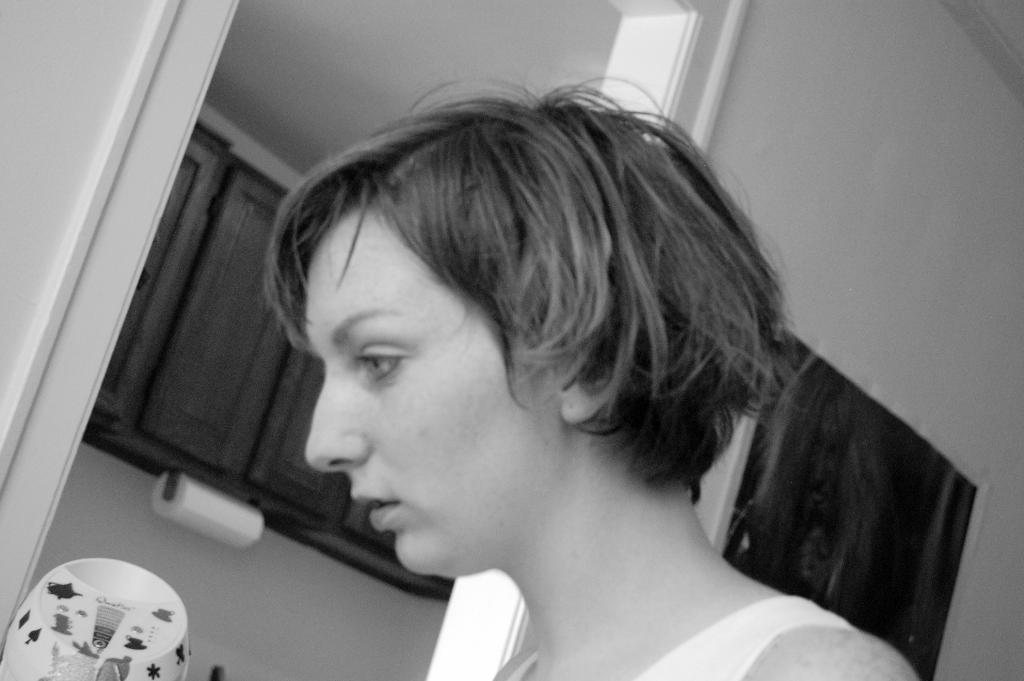What is the color scheme of the image? The image is black and white. Can you describe the main subject in the image? There is a person in the image. What type of furniture can be seen in the image? There are cupboards in the image. What item is present for cleaning or personal use? There is a tissue roll in the image. What is the background of the image made of? There is a wall in the image. What else is present in the image besides the person and cupboards? There is an object in the image. How many cakes are being served in the image? There are no cakes present in the image. What emotion does the person in the image express regarding their regret? There is no indication of regret or any emotions in the image, as it is a simple black and white depiction of a person, cupboards, a tissue roll, a wall, and an object. 